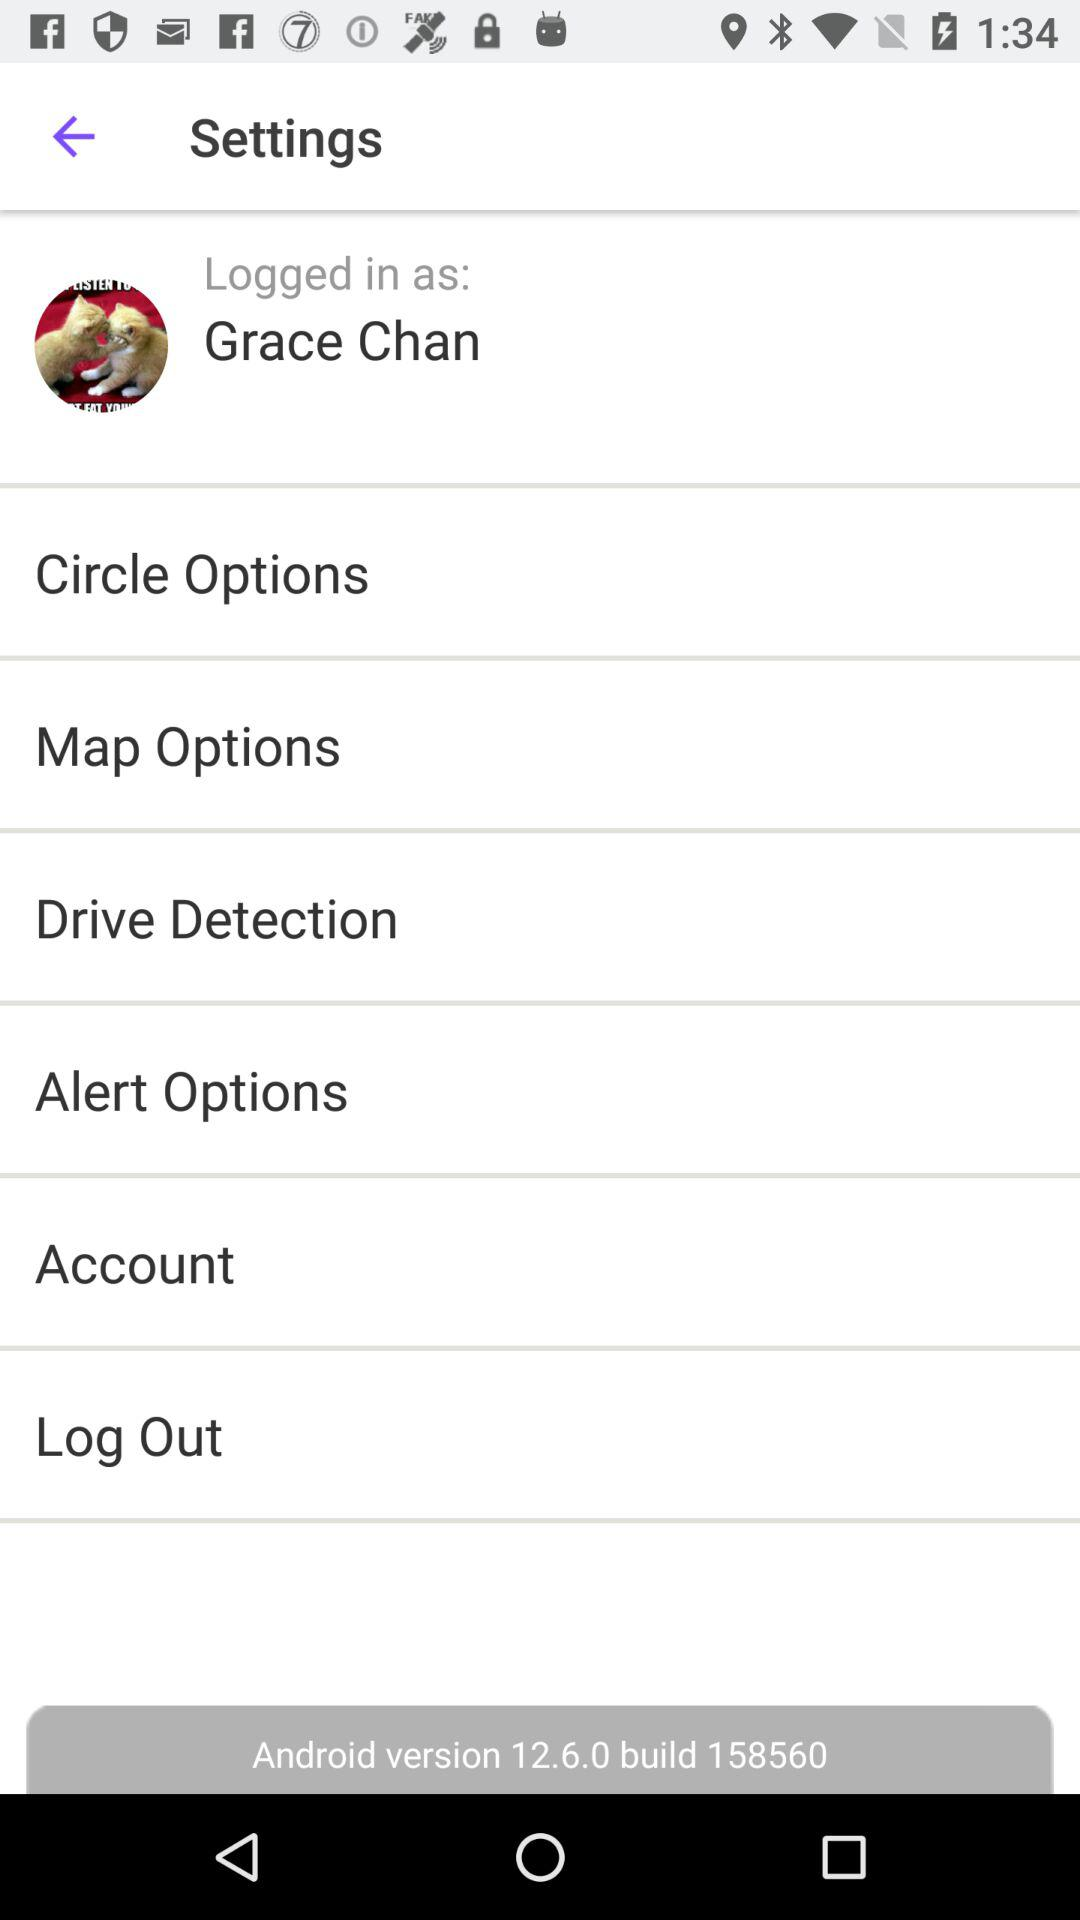What is the Android version? The Android version is 12.6.0. 